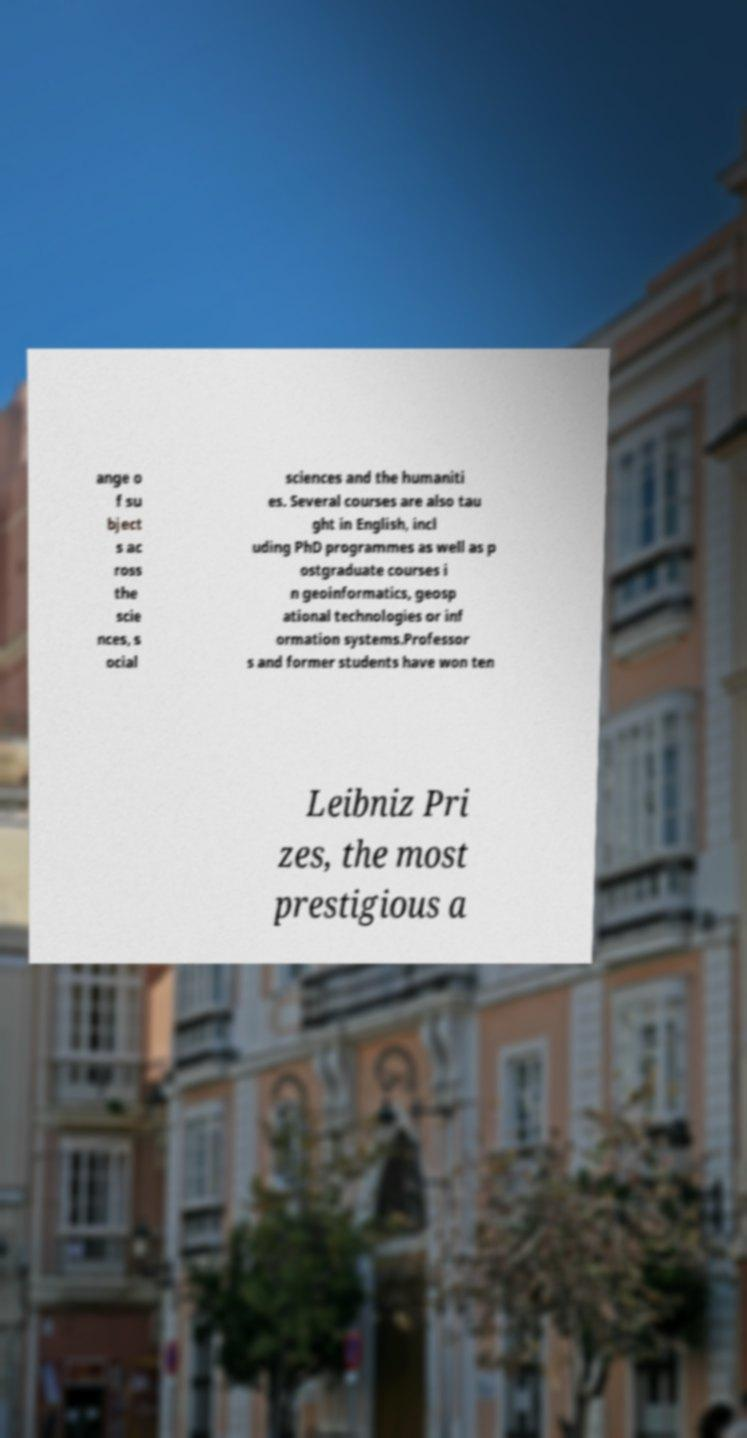Can you accurately transcribe the text from the provided image for me? ange o f su bject s ac ross the scie nces, s ocial sciences and the humaniti es. Several courses are also tau ght in English, incl uding PhD programmes as well as p ostgraduate courses i n geoinformatics, geosp ational technologies or inf ormation systems.Professor s and former students have won ten Leibniz Pri zes, the most prestigious a 